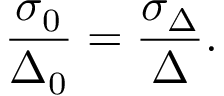Convert formula to latex. <formula><loc_0><loc_0><loc_500><loc_500>\frac { \sigma _ { 0 } } { \Delta _ { 0 } } = \frac { \sigma _ { \Delta } } { \Delta } .</formula> 